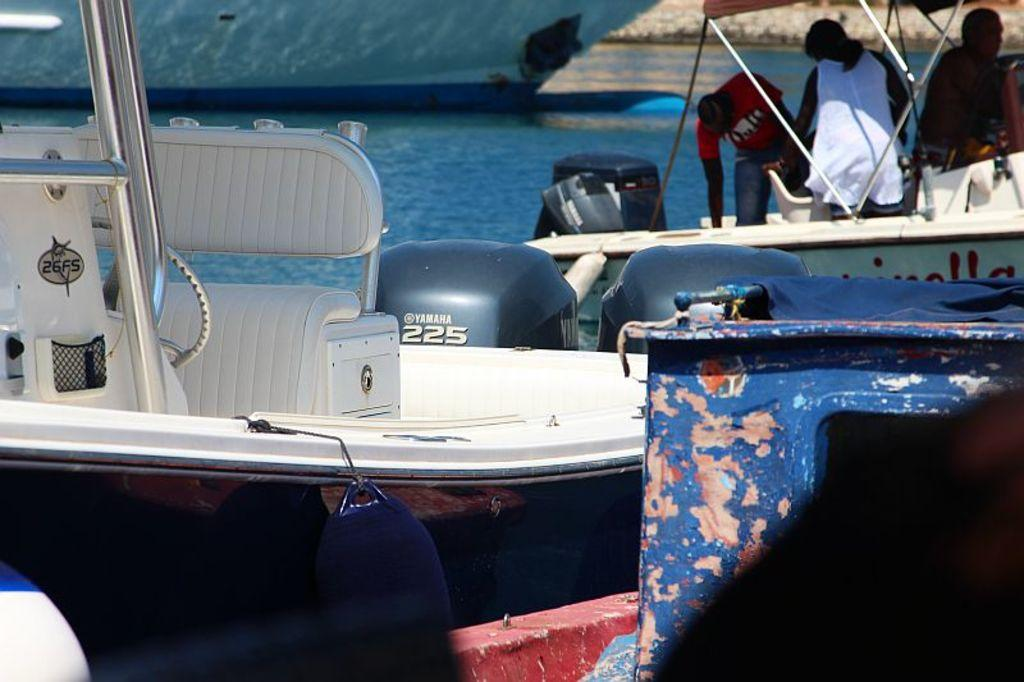What is the main subject of the image? The main subject of the image is boats. Where are the boats located? The boats are on the water. Can you describe the people in the image? There are people standing in a boat on the right side of the image. What type of zebra can be seen grazing on grain in the image? There is no zebra or grain present in the image; it features boats on the water with people standing in one of them. 